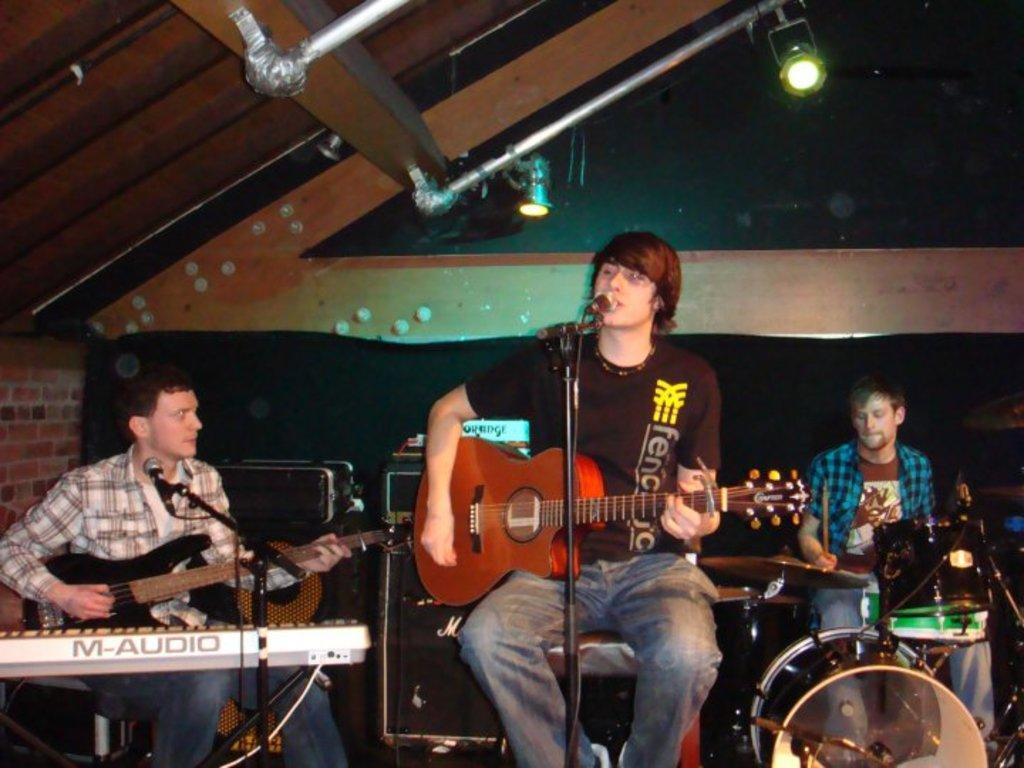Can you describe this image briefly? In this picture we can see three men sitting on stool where two are holding guitars in their hands and playing it and one is playing drums and in middle person singing on mic and in background we can see wall, lights, rods, speakers. 